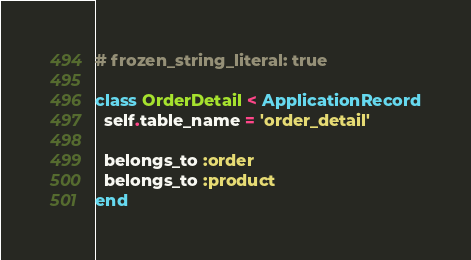<code> <loc_0><loc_0><loc_500><loc_500><_Ruby_># frozen_string_literal: true

class OrderDetail < ApplicationRecord
  self.table_name = 'order_detail'

  belongs_to :order
  belongs_to :product
end
</code> 